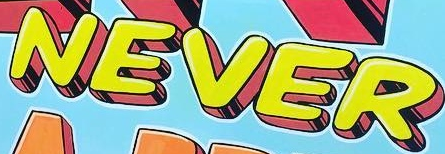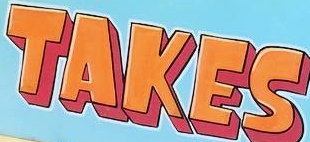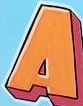Read the text from these images in sequence, separated by a semicolon. NEVER; TAKES; A 